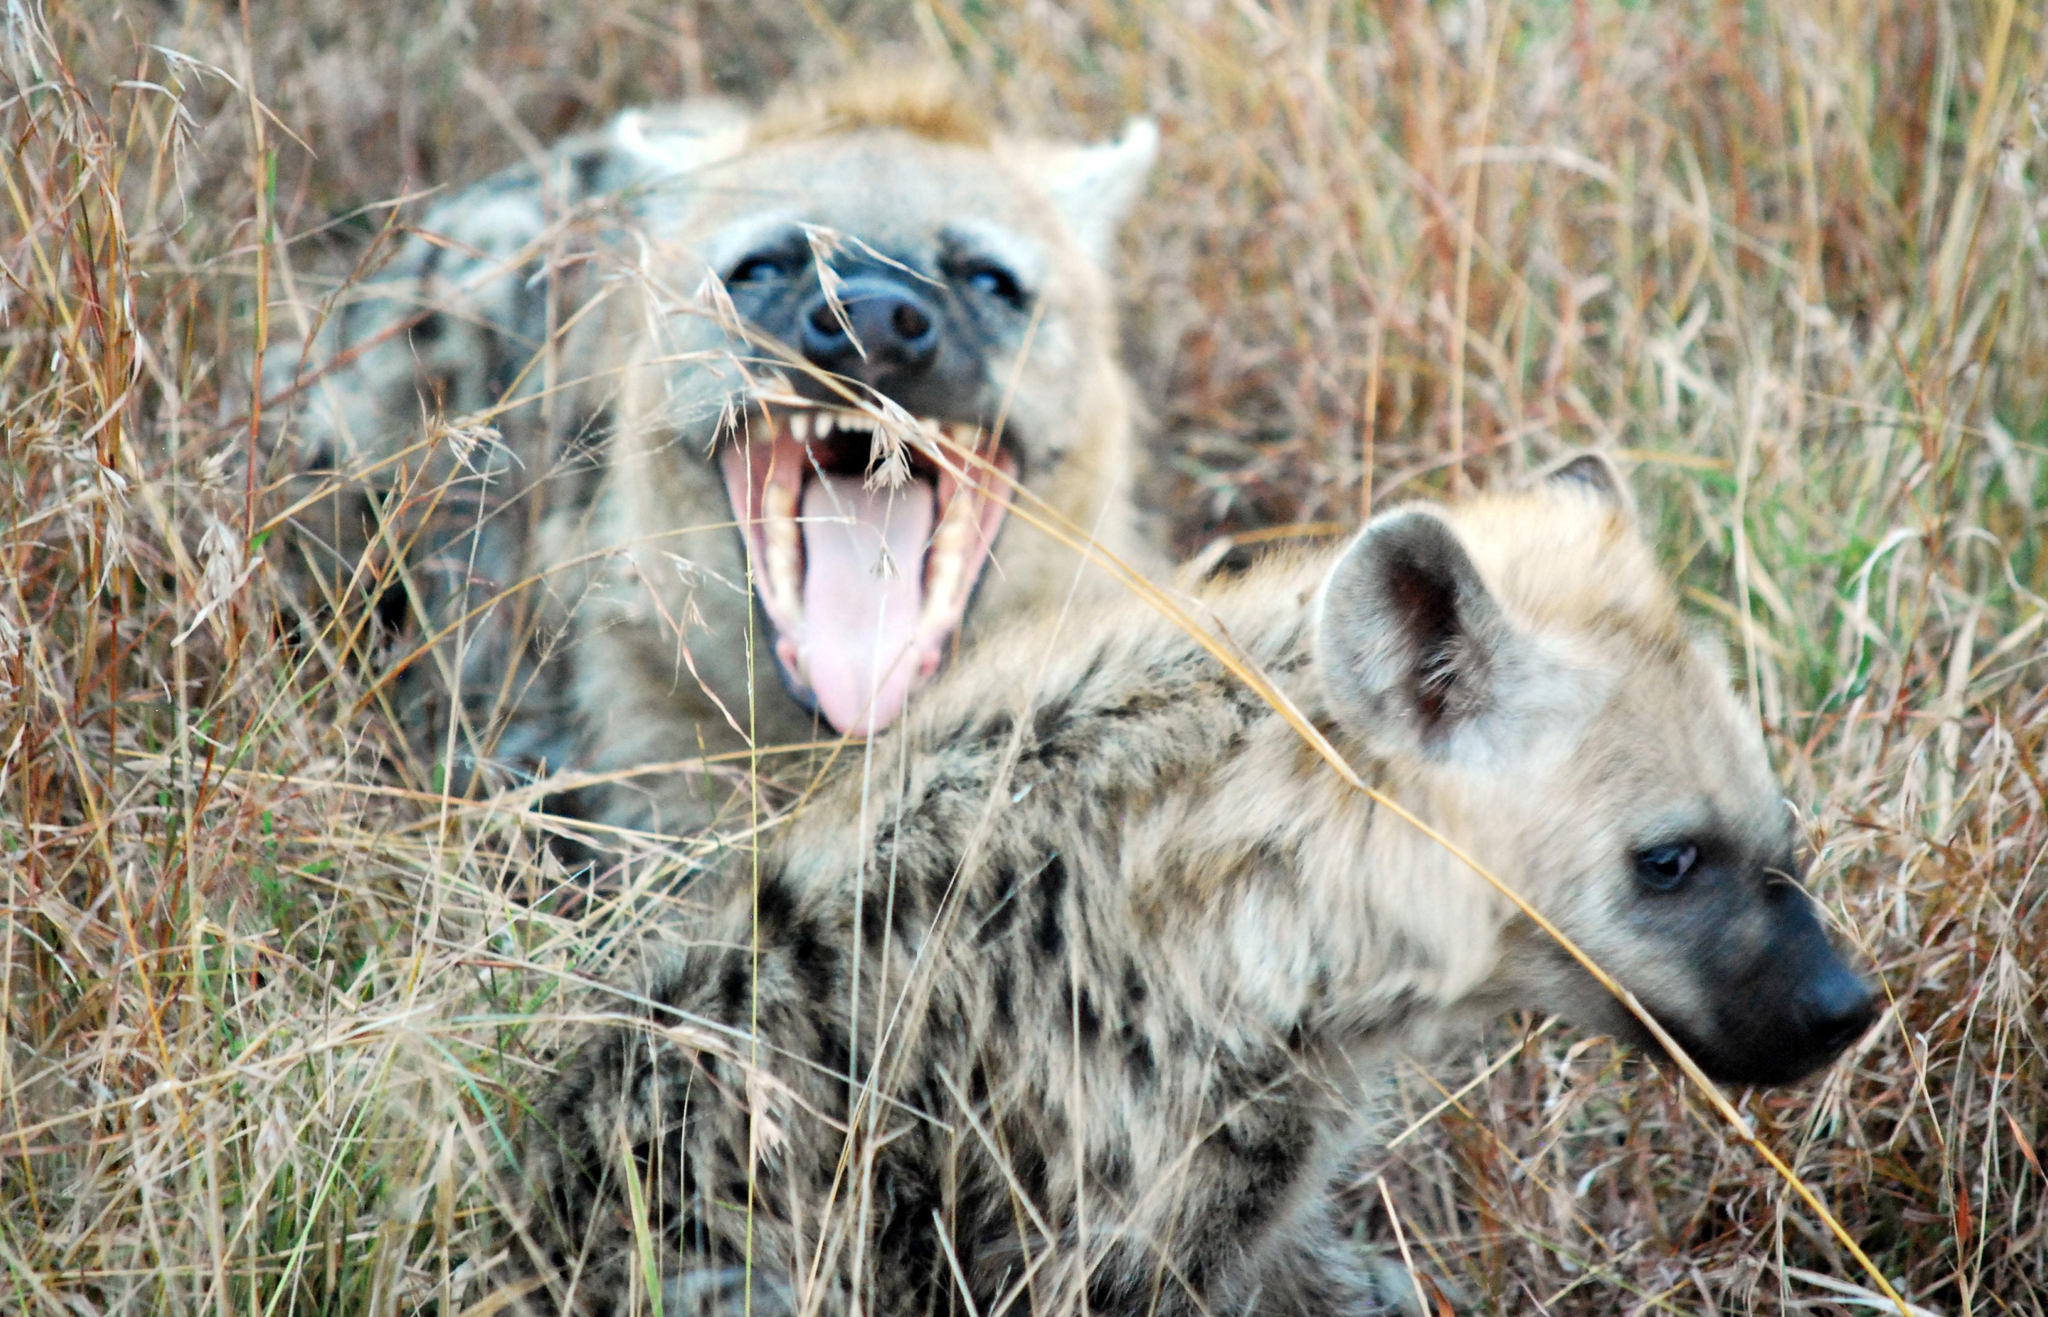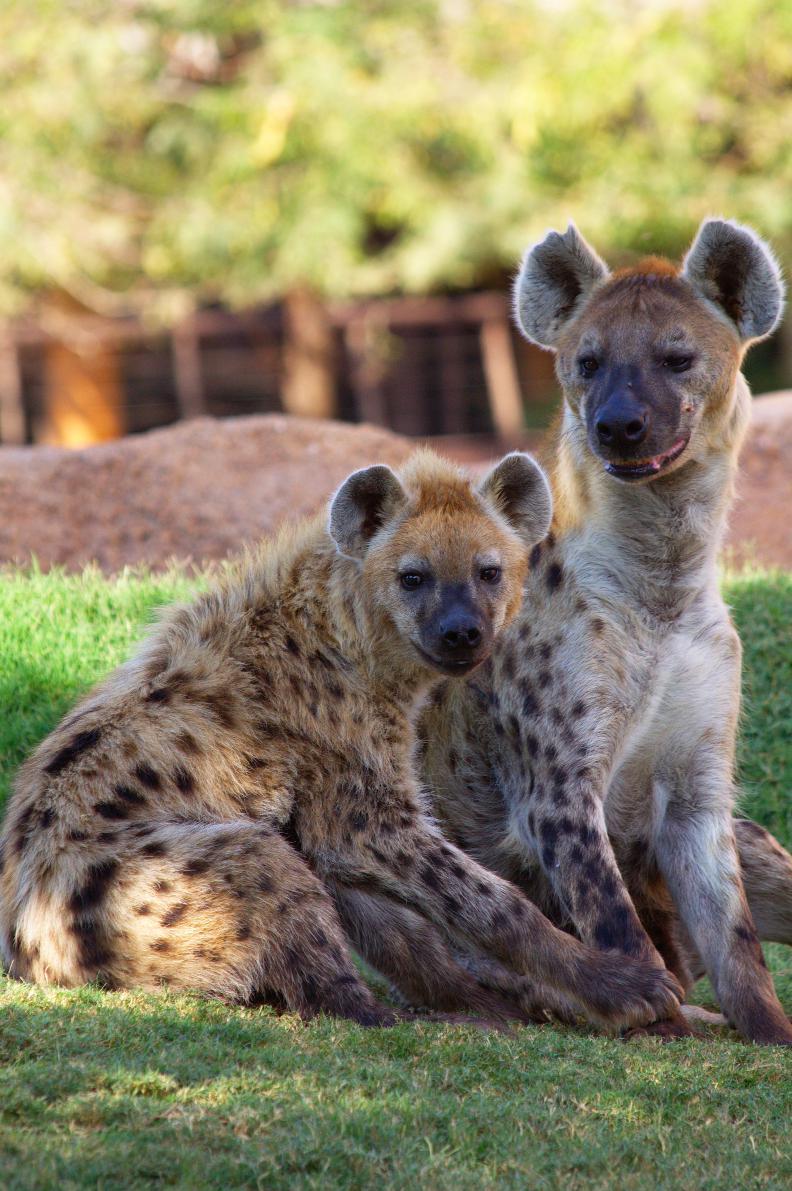The first image is the image on the left, the second image is the image on the right. Examine the images to the left and right. Is the description "Each image contains multiple hyenas, and one image shows a fang-baring hyena next to one other hyena." accurate? Answer yes or no. Yes. The first image is the image on the left, the second image is the image on the right. Analyze the images presented: Is the assertion "There are at least two hyenas in each image." valid? Answer yes or no. Yes. 